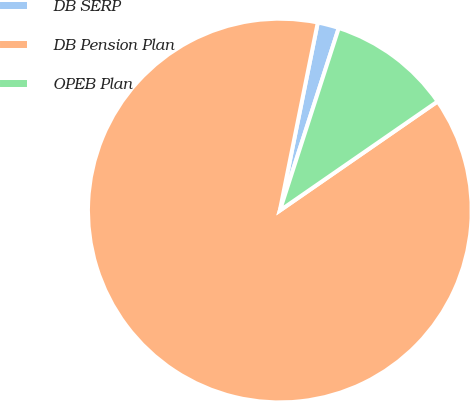Convert chart to OTSL. <chart><loc_0><loc_0><loc_500><loc_500><pie_chart><fcel>DB SERP<fcel>DB Pension Plan<fcel>OPEB Plan<nl><fcel>1.8%<fcel>87.8%<fcel>10.4%<nl></chart> 